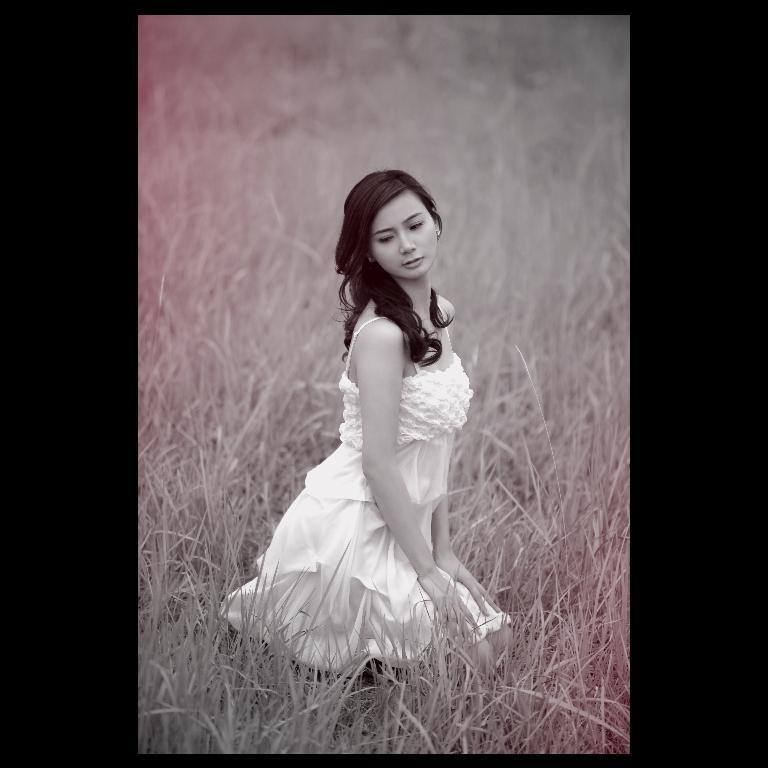Who is the main subject in the image? A: There is a woman in the image. What is the woman wearing? The woman is wearing a white skirt. What type of surface is the woman standing on? The woman is standing on grass. Can you provide an example of the woman's favorite activity in the image? There is no specific activity depicted in the image, so it is not possible to provide an example of the woman's favorite activity. 